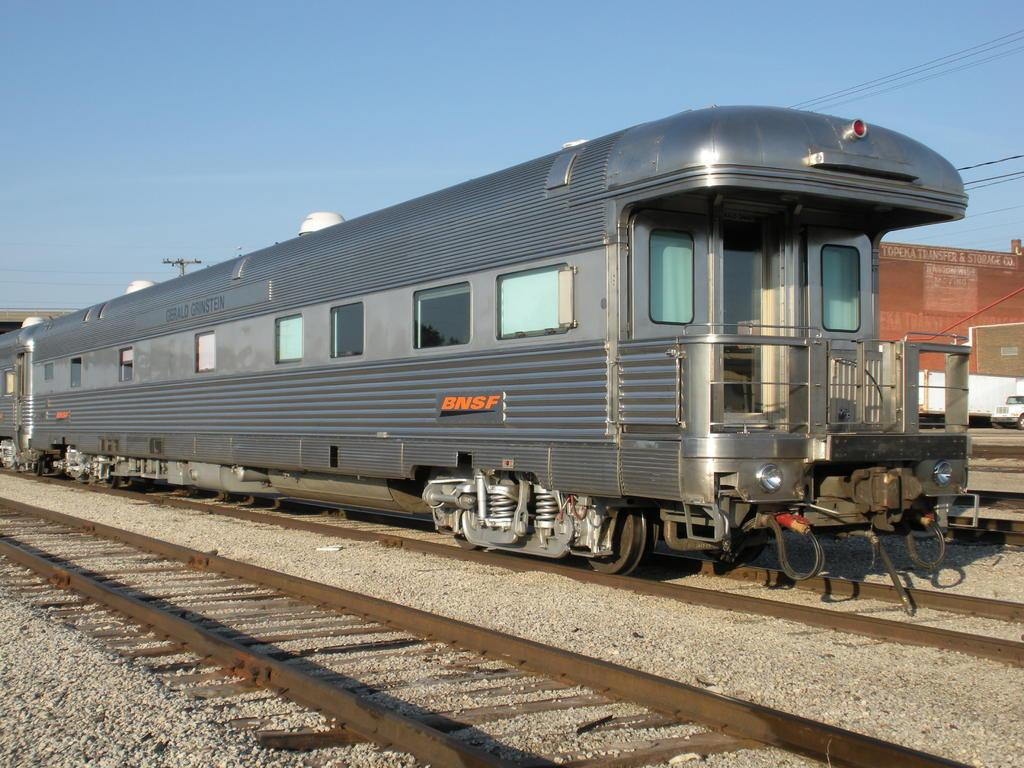What is the main subject of the image? The main subject of the image is a train. What can be seen beneath the train in the image? There are railway tracks in the image. What is visible at the top of the image? The sky is visible at the top of the image. What type of dust can be seen on the tray in the image? There is no tray or dust present in the image; it features a train on railway tracks with the sky visible at the top. 